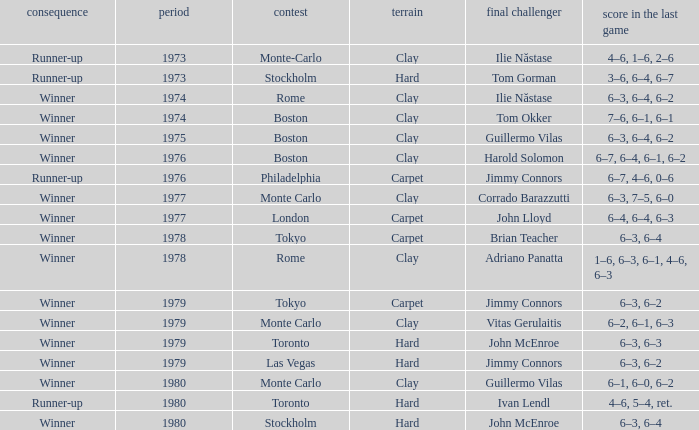Name the year for clay for boston and guillermo vilas 1975.0. 